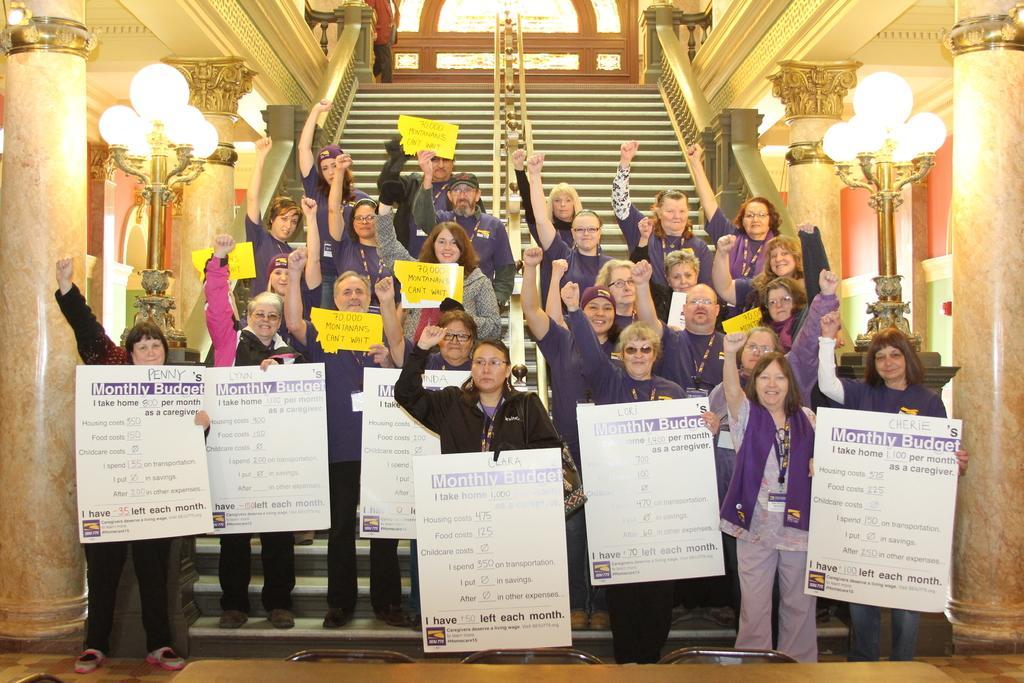Could you give a brief overview of what you see in this image? In this picture we can see a group of people standing on steps, holding posters with their hands and in the background we can see pillars, light poles, walls, some objects. 